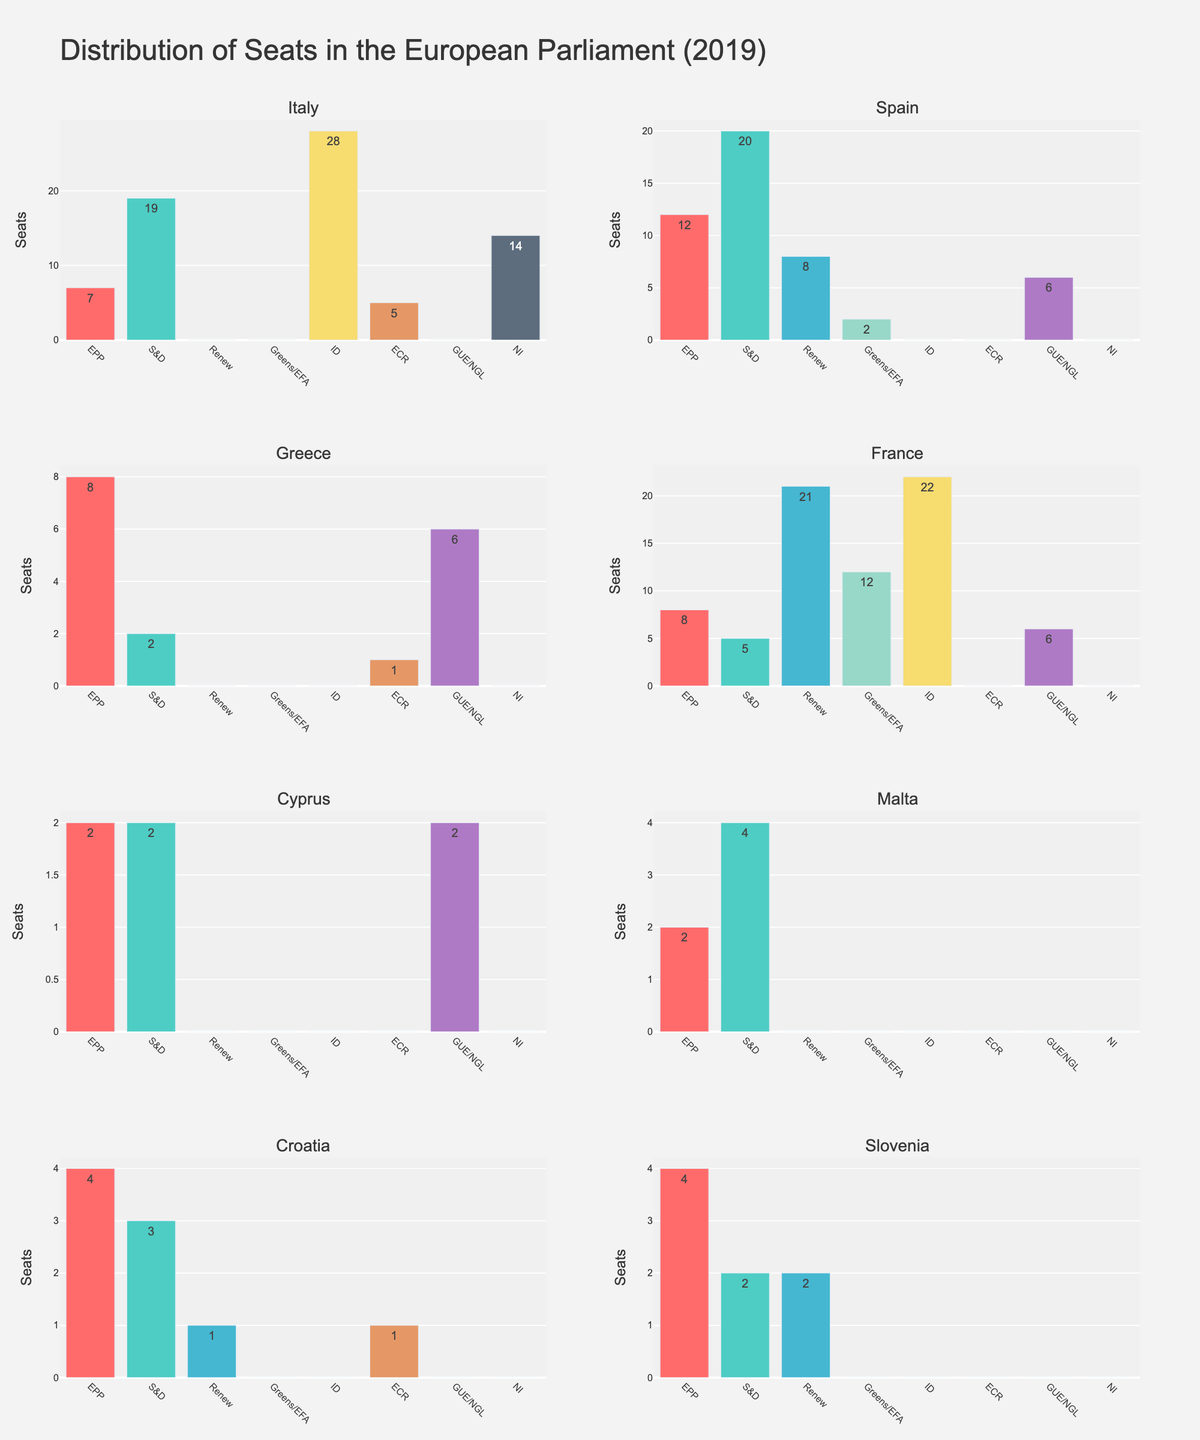What is the total number of seats for Italy? By looking at the Italy subplot, sum the number of seats for each party: (7 + 19 + 0 + 0 + 28 + 5 + 0 + 14) = 73
Answer: 73 Which country has the highest number of seats in the EPP party? Compare the EPP seats in all subplots: Italy (7), Spain (12), Greece (8), France (8), Cyprus (2), Malta (2), Croatia (4), Slovenia (4). Spain has the highest number of EPP seats with 12.
Answer: Spain How many more seats does Spain's S&D party have compared to France's S&D party? Spain's S&D has 20 seats, France's S&D has 5 seats. Subtract: 20 - 5 = 15
Answer: 15 Which countries have no seats in the ID party? Check each subplot for the ID party column: Spain, Greece, Cyprus, Malta, Croatia, and Slovenia have 0 seats in the ID party.
Answer: Spain, Greece, Cyprus, Malta, Croatia, Slovenia What is the average number of seats held by the GUE/NGL party across all countries? Calculate the total seats: (0+6+6+6+2+0+0+0) = 20. There are 8 countries. Average = 20 / 8 = 2.5
Answer: 2.5 Which country has the most diverse seat distribution across different parties? Look for the subplot where seats are distributed more evenly across different parties. France has a significant spread across multiple parties: (8, 5, 21, 12, 22, 0, 6, 0).
Answer: France How many countries have more than 2 parties represented in the parliament? Check each subplot for the number of parties with more than 0 seats: Italy (4), Spain (3), Greece (3), France (5), Cyprus (2), Malta (2), Croatia (3), Slovenia (3). Total = 6 countries.
Answer: 6 Which party has the least total number of seats across all Mediterranean countries? Sum the seats for each party across all subplots and compare: Renew (32), Greens/EFA (14), ECR (7), ID (50), S&D (55), EPP (47), GUE/NGL (20), NI (14). ECR has the least with 7 seats.
Answer: ECR What is the difference in the total number of seats between Spain’s S&D party and Cyprus's total seats? Spain's S&D has 20 seats, Cyprus has a total of (2+2+0+0+0+0+2+0) = 6 seats. Difference: 20 - 6 = 14
Answer: 14 